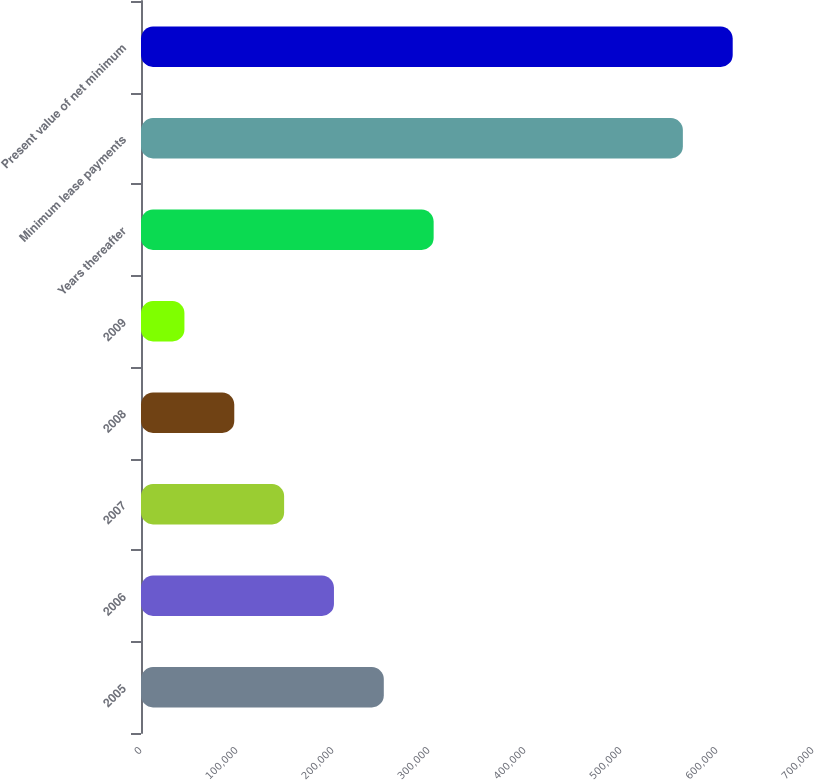<chart> <loc_0><loc_0><loc_500><loc_500><bar_chart><fcel>2005<fcel>2006<fcel>2007<fcel>2008<fcel>2009<fcel>Years thereafter<fcel>Minimum lease payments<fcel>Present value of net minimum<nl><fcel>252920<fcel>201000<fcel>149080<fcel>97160.1<fcel>45240<fcel>304840<fcel>564441<fcel>616361<nl></chart> 